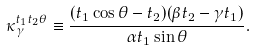Convert formula to latex. <formula><loc_0><loc_0><loc_500><loc_500>\kappa ^ { t _ { 1 } t _ { 2 } \theta } _ { \gamma } \equiv \frac { ( t _ { 1 } \cos \theta - t _ { 2 } ) ( \beta t _ { 2 } - \gamma t _ { 1 } ) } { \alpha t _ { 1 } \sin \theta } .</formula> 